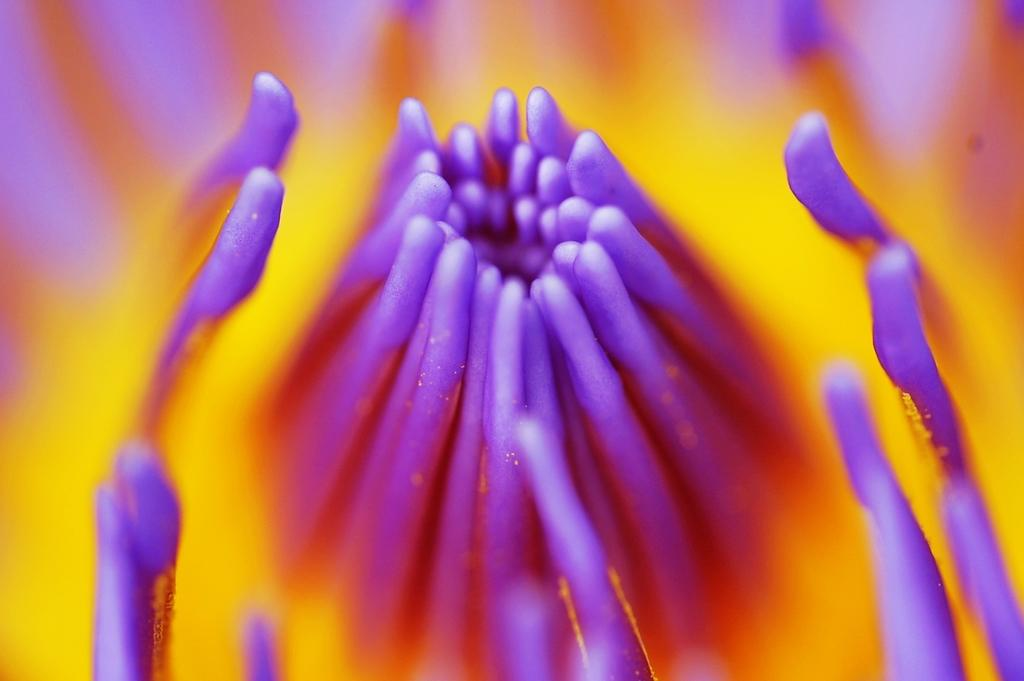What is the main subject of the image? There is a flower in the image. How many notes are visible on the flower in the image? There are no notes present on the flower in the image. What type of frogs can be seen interacting with the flower in the image? There are no frogs present in the image; it features only a flower. 